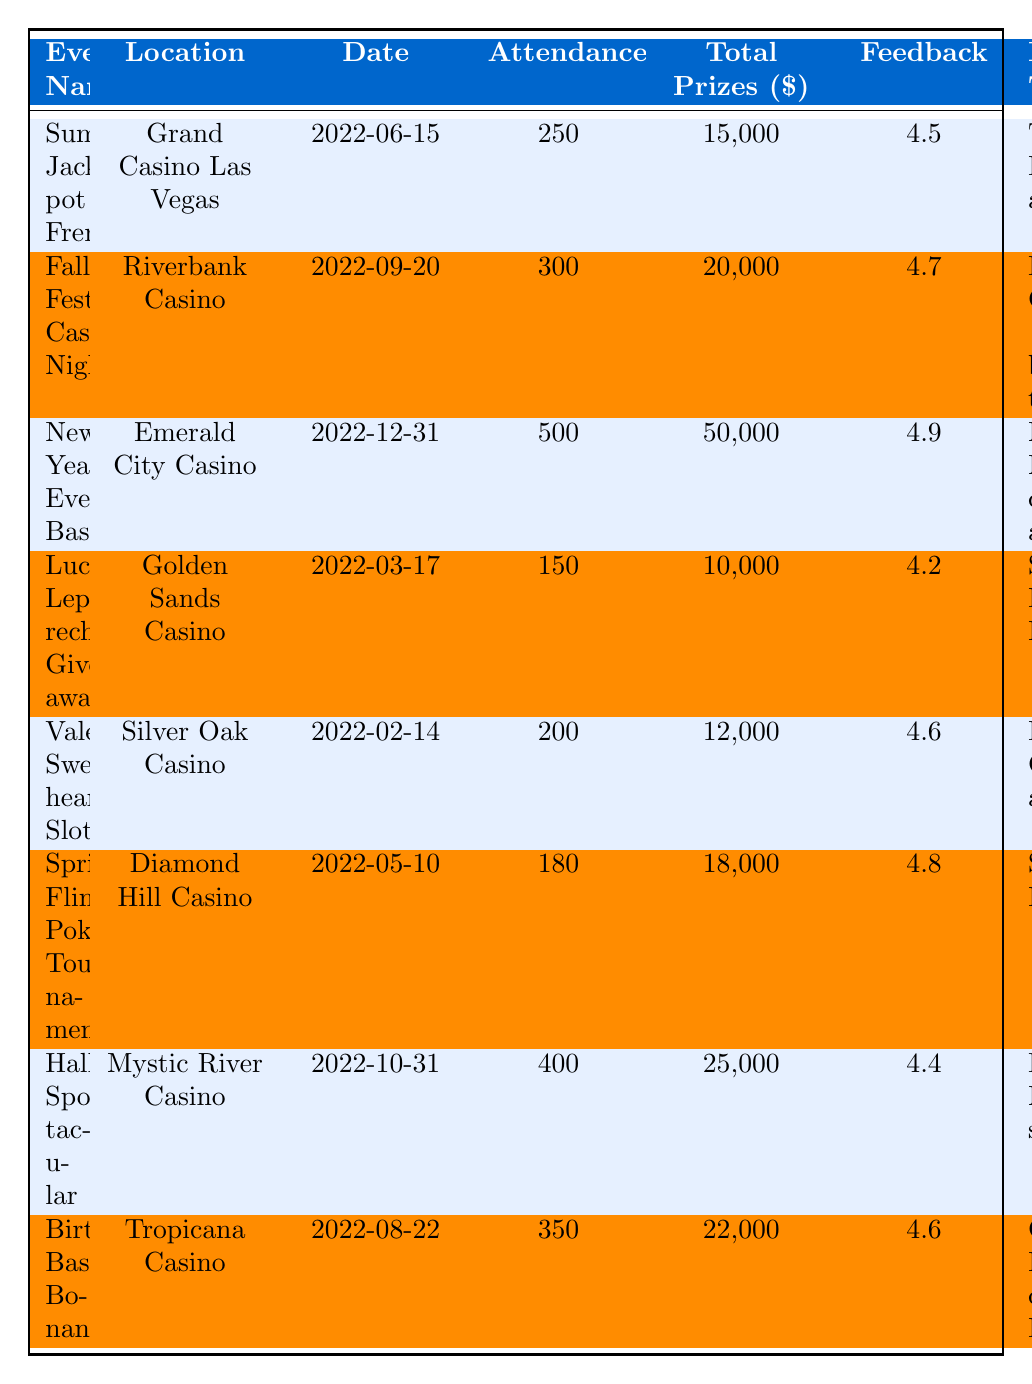What is the date of the "Fall Fest Casino Night" event? The table lists the date for each event, and for "Fall Fest Casino Night," it shows the date as 2022-09-20.
Answer: 2022-09-20 Which event had the highest attendance? By comparing the attendance values for each event, "New Year's Eve Bash" had the highest attendance at 500.
Answer: 500 What was the total amount of prizes awarded for the "Halloween Spooktacular" event? Referring to the table, the "Halloween Spooktacular" event shows a total prizes awarded amount of 25,000.
Answer: 25,000 How many hours did participants spend on average at the "Spring Fling Poker Tournament"? The table states that the average play time for the "Spring Fling Poker Tournament" was 4.5 hours.
Answer: 4.5 hours What was the average feedback score among all events? To find the average feedback score, sum all feedback scores (4.5 + 4.7 + 4.9 + 4.2 + 4.6 + 4.8 + 4.4 + 4.6 = 36.7) and divide by the number of events (8): 36.7 / 8 = 4.5875, rounded to 4.59.
Answer: 4.59 How does the attendance of "Lucky Leprechaun Giveaway" compare to the average attendance of all events? The attendance for "Lucky Leprechaun Giveaway" is 150. To find the average attendance, sum all attendance values (250 + 300 + 500 + 150 + 200 + 180 + 400 + 350 = 1930) and divide by the number of events (8): 1930 / 8 = 241.25. Since 150 is below 241.25, it's lower than average.
Answer: Lower than average Were there more participants at the "Summer Jackpot Frenzy" or the "Valentine's Sweetheart Slots"? The attendance for the "Summer Jackpot Frenzy" is 250, while for "Valentine's Sweetheart Slots" it is 200. Since 250 is greater than 200, "Summer Jackpot Frenzy" had more participants.
Answer: "Summer Jackpot Frenzy" What was the difference in total prizes awarded between the "New Year's Eve Bash" and "Valentine's Sweetheart Slots"? The total prizes for "New Year's Eve Bash" is 50,000 and for "Valentine's Sweetheart Slots" is 12,000. The difference is calculated as 50,000 - 12,000 = 38,000.
Answer: 38,000 Did the "Fall Fest Casino Night" have a higher participant feedback score than the "Lucky Leprechaun Giveaway"? The feedback score for "Fall Fest Casino Night" is 4.7 while for "Lucky Leprechaun Giveaway" it is 4.2. Since 4.7 is higher than 4.2, it confirms that "Fall Fest Casino Night" had a higher score.
Answer: Yes What was the highest average playtime for any event? Comparing the average playtime values, "New Year's Eve Bash" had the highest average playtime of 5 hours, more than all other events.
Answer: 5 hours 